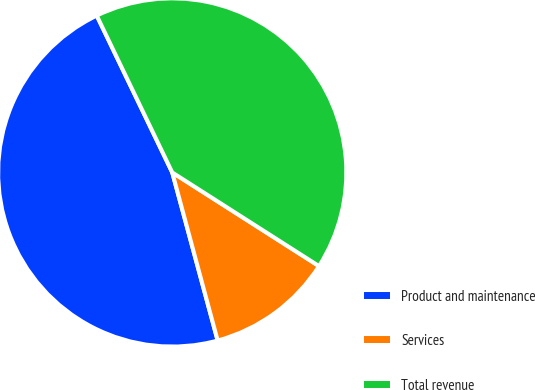Convert chart. <chart><loc_0><loc_0><loc_500><loc_500><pie_chart><fcel>Product and maintenance<fcel>Services<fcel>Total revenue<nl><fcel>47.06%<fcel>11.76%<fcel>41.18%<nl></chart> 